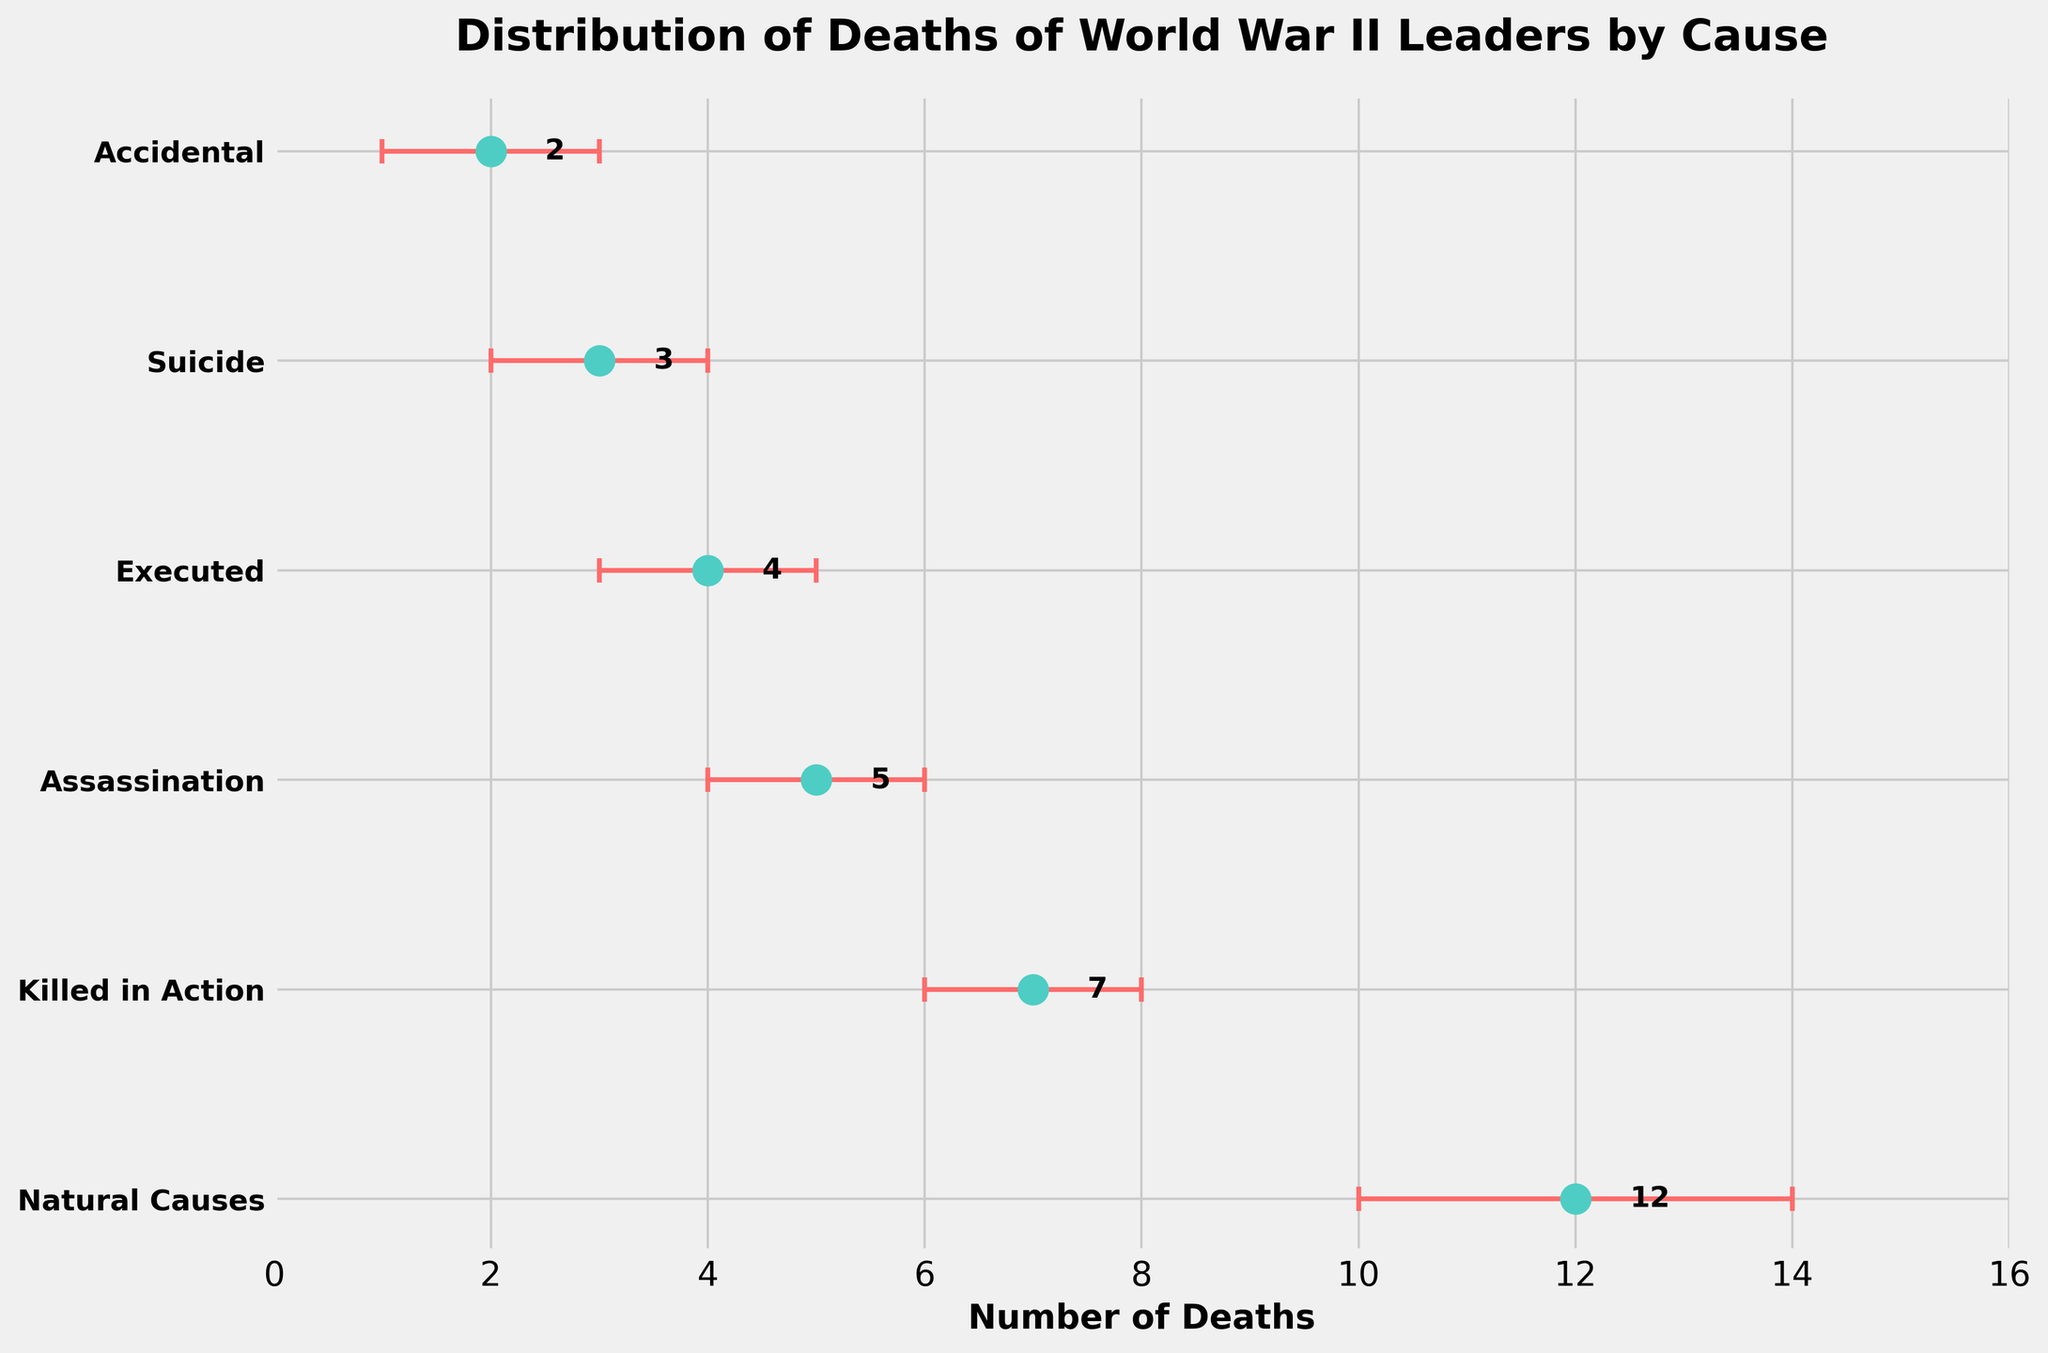What is the title of the plot? The title of the plot is found at the top; it indicates the subject of the figure.
Answer: Distribution of Deaths of World War II Leaders by Cause How many causes of death are listed in the figure? Count the number of labeled y-axis categories.
Answer: 6 Which cause of death has the highest mean number of deaths? Look for the data point positioned furthest to the right on the x-axis.
Answer: Natural Causes What is the mean number of deaths for executed World War II leaders? Read the number associated with the "Executed" category on the y-axis.
Answer: 4 Which cause of death has the smallest error range? Identify the smallest error bar range. Note that more than one cause might have the same range.
Answer: Killed in Action, Assassination, Executed, Suicide, Accidental By how many deaths does "Natural Causes" exceed "Killed in Action" in mean number of deaths? Subtract the mean number of deaths for "Killed in Action" from that of "Natural Causes".
Answer: 5 If you combine the mean number of deaths from "Assassination" and "Executed," how many do you get? Sum the mean numbers of deaths for both categories.
Answer: 9 Which cause(s) of death could potentially have a mean number of deaths as high as 7, considering the error ranges? Check the upper limit of the error range for each category to see if it reaches or exceeds 7.
Answer: Killed in Action, Assassination Which category has the lowest mean number of deaths? Identify the category positioned furthest to the left on the x-axis.
Answer: Accidental How does the mean number of deaths for "Suicide" compare to "Accidental"? Compare the mean numbers of deaths for "Suicide" and "Accidental".
Answer: Suicide is higher 